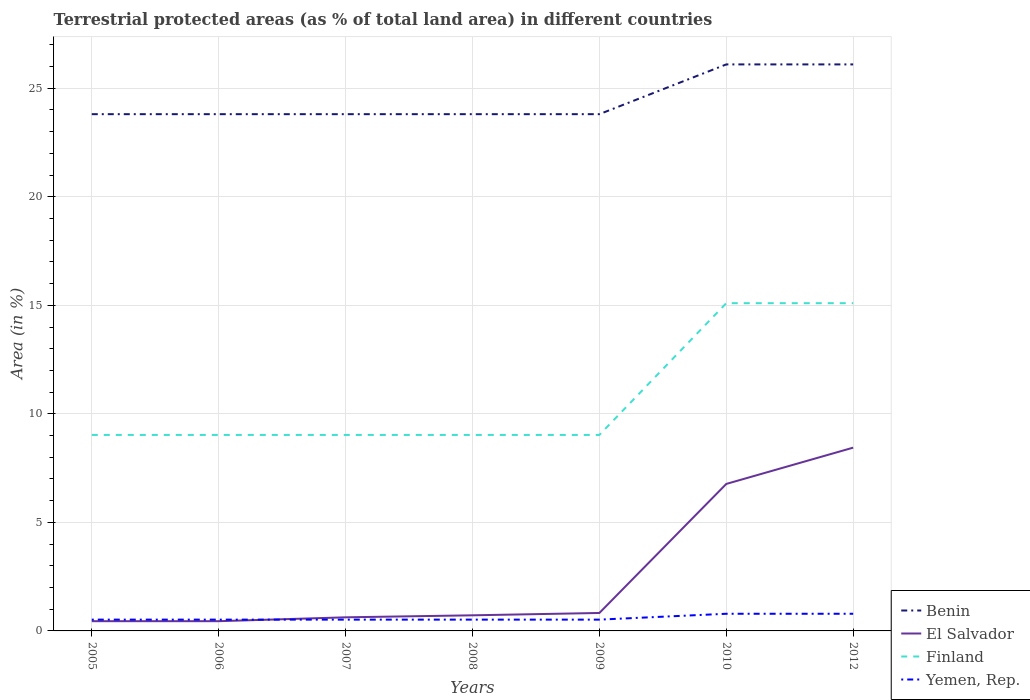How many different coloured lines are there?
Provide a short and direct response. 4. Across all years, what is the maximum percentage of terrestrial protected land in El Salvador?
Ensure brevity in your answer.  0.45. What is the total percentage of terrestrial protected land in Benin in the graph?
Keep it short and to the point. 3.0140014928292658e-9. What is the difference between the highest and the second highest percentage of terrestrial protected land in El Salvador?
Ensure brevity in your answer.  8. Is the percentage of terrestrial protected land in Benin strictly greater than the percentage of terrestrial protected land in Finland over the years?
Give a very brief answer. No. Does the graph contain any zero values?
Offer a very short reply. No. Does the graph contain grids?
Give a very brief answer. Yes. Where does the legend appear in the graph?
Give a very brief answer. Bottom right. How many legend labels are there?
Offer a very short reply. 4. How are the legend labels stacked?
Keep it short and to the point. Vertical. What is the title of the graph?
Your response must be concise. Terrestrial protected areas (as % of total land area) in different countries. What is the label or title of the Y-axis?
Your response must be concise. Area (in %). What is the Area (in %) of Benin in 2005?
Your answer should be compact. 23.81. What is the Area (in %) of El Salvador in 2005?
Offer a terse response. 0.45. What is the Area (in %) in Finland in 2005?
Your answer should be compact. 9.03. What is the Area (in %) in Yemen, Rep. in 2005?
Your answer should be compact. 0.52. What is the Area (in %) of Benin in 2006?
Your response must be concise. 23.81. What is the Area (in %) of El Salvador in 2006?
Keep it short and to the point. 0.45. What is the Area (in %) of Finland in 2006?
Offer a very short reply. 9.03. What is the Area (in %) in Yemen, Rep. in 2006?
Offer a terse response. 0.52. What is the Area (in %) in Benin in 2007?
Your answer should be very brief. 23.81. What is the Area (in %) of El Salvador in 2007?
Offer a very short reply. 0.63. What is the Area (in %) of Finland in 2007?
Give a very brief answer. 9.03. What is the Area (in %) in Yemen, Rep. in 2007?
Your answer should be very brief. 0.52. What is the Area (in %) of Benin in 2008?
Your answer should be very brief. 23.81. What is the Area (in %) of El Salvador in 2008?
Provide a short and direct response. 0.72. What is the Area (in %) of Finland in 2008?
Give a very brief answer. 9.03. What is the Area (in %) in Yemen, Rep. in 2008?
Offer a terse response. 0.52. What is the Area (in %) of Benin in 2009?
Offer a terse response. 23.81. What is the Area (in %) of El Salvador in 2009?
Your response must be concise. 0.83. What is the Area (in %) of Finland in 2009?
Provide a short and direct response. 9.03. What is the Area (in %) of Yemen, Rep. in 2009?
Offer a terse response. 0.52. What is the Area (in %) of Benin in 2010?
Offer a very short reply. 26.1. What is the Area (in %) in El Salvador in 2010?
Make the answer very short. 6.77. What is the Area (in %) in Finland in 2010?
Offer a very short reply. 15.1. What is the Area (in %) in Yemen, Rep. in 2010?
Provide a succinct answer. 0.79. What is the Area (in %) of Benin in 2012?
Your answer should be compact. 26.1. What is the Area (in %) in El Salvador in 2012?
Your response must be concise. 8.44. What is the Area (in %) in Finland in 2012?
Your answer should be compact. 15.1. What is the Area (in %) in Yemen, Rep. in 2012?
Keep it short and to the point. 0.79. Across all years, what is the maximum Area (in %) in Benin?
Provide a short and direct response. 26.1. Across all years, what is the maximum Area (in %) of El Salvador?
Keep it short and to the point. 8.44. Across all years, what is the maximum Area (in %) in Finland?
Provide a succinct answer. 15.1. Across all years, what is the maximum Area (in %) of Yemen, Rep.?
Your answer should be very brief. 0.79. Across all years, what is the minimum Area (in %) of Benin?
Provide a succinct answer. 23.81. Across all years, what is the minimum Area (in %) of El Salvador?
Offer a terse response. 0.45. Across all years, what is the minimum Area (in %) of Finland?
Provide a short and direct response. 9.03. Across all years, what is the minimum Area (in %) in Yemen, Rep.?
Your answer should be compact. 0.52. What is the total Area (in %) in Benin in the graph?
Give a very brief answer. 171.24. What is the total Area (in %) of El Salvador in the graph?
Keep it short and to the point. 18.28. What is the total Area (in %) of Finland in the graph?
Provide a succinct answer. 75.34. What is the total Area (in %) in Yemen, Rep. in the graph?
Offer a very short reply. 4.18. What is the difference between the Area (in %) of Benin in 2005 and that in 2006?
Your response must be concise. 0. What is the difference between the Area (in %) in El Salvador in 2005 and that in 2006?
Your answer should be compact. 0. What is the difference between the Area (in %) of Finland in 2005 and that in 2006?
Offer a very short reply. -0. What is the difference between the Area (in %) of Benin in 2005 and that in 2007?
Offer a terse response. 0. What is the difference between the Area (in %) of El Salvador in 2005 and that in 2007?
Ensure brevity in your answer.  -0.18. What is the difference between the Area (in %) in Finland in 2005 and that in 2007?
Provide a short and direct response. -0. What is the difference between the Area (in %) in Yemen, Rep. in 2005 and that in 2007?
Provide a short and direct response. 0. What is the difference between the Area (in %) in Benin in 2005 and that in 2008?
Your response must be concise. 0. What is the difference between the Area (in %) of El Salvador in 2005 and that in 2008?
Give a very brief answer. -0.27. What is the difference between the Area (in %) in Finland in 2005 and that in 2008?
Make the answer very short. -0. What is the difference between the Area (in %) of Benin in 2005 and that in 2009?
Provide a succinct answer. 0. What is the difference between the Area (in %) of El Salvador in 2005 and that in 2009?
Give a very brief answer. -0.38. What is the difference between the Area (in %) of Yemen, Rep. in 2005 and that in 2009?
Offer a terse response. 0. What is the difference between the Area (in %) of Benin in 2005 and that in 2010?
Offer a very short reply. -2.29. What is the difference between the Area (in %) in El Salvador in 2005 and that in 2010?
Give a very brief answer. -6.32. What is the difference between the Area (in %) of Finland in 2005 and that in 2010?
Your answer should be compact. -6.07. What is the difference between the Area (in %) in Yemen, Rep. in 2005 and that in 2010?
Keep it short and to the point. -0.27. What is the difference between the Area (in %) of Benin in 2005 and that in 2012?
Ensure brevity in your answer.  -2.29. What is the difference between the Area (in %) in El Salvador in 2005 and that in 2012?
Offer a very short reply. -8. What is the difference between the Area (in %) in Finland in 2005 and that in 2012?
Make the answer very short. -6.07. What is the difference between the Area (in %) of Yemen, Rep. in 2005 and that in 2012?
Your response must be concise. -0.27. What is the difference between the Area (in %) in El Salvador in 2006 and that in 2007?
Make the answer very short. -0.18. What is the difference between the Area (in %) in Benin in 2006 and that in 2008?
Your answer should be compact. 0. What is the difference between the Area (in %) of El Salvador in 2006 and that in 2008?
Your response must be concise. -0.27. What is the difference between the Area (in %) of Finland in 2006 and that in 2008?
Provide a succinct answer. -0. What is the difference between the Area (in %) in Benin in 2006 and that in 2009?
Give a very brief answer. 0. What is the difference between the Area (in %) in El Salvador in 2006 and that in 2009?
Your answer should be compact. -0.38. What is the difference between the Area (in %) of Yemen, Rep. in 2006 and that in 2009?
Your response must be concise. 0. What is the difference between the Area (in %) of Benin in 2006 and that in 2010?
Your answer should be very brief. -2.29. What is the difference between the Area (in %) of El Salvador in 2006 and that in 2010?
Provide a short and direct response. -6.32. What is the difference between the Area (in %) of Finland in 2006 and that in 2010?
Offer a terse response. -6.07. What is the difference between the Area (in %) of Yemen, Rep. in 2006 and that in 2010?
Offer a very short reply. -0.27. What is the difference between the Area (in %) of Benin in 2006 and that in 2012?
Offer a very short reply. -2.29. What is the difference between the Area (in %) in El Salvador in 2006 and that in 2012?
Give a very brief answer. -8. What is the difference between the Area (in %) in Finland in 2006 and that in 2012?
Offer a very short reply. -6.07. What is the difference between the Area (in %) of Yemen, Rep. in 2006 and that in 2012?
Ensure brevity in your answer.  -0.27. What is the difference between the Area (in %) in Benin in 2007 and that in 2008?
Make the answer very short. 0. What is the difference between the Area (in %) of El Salvador in 2007 and that in 2008?
Offer a very short reply. -0.09. What is the difference between the Area (in %) of Finland in 2007 and that in 2008?
Provide a short and direct response. -0. What is the difference between the Area (in %) of El Salvador in 2007 and that in 2009?
Make the answer very short. -0.2. What is the difference between the Area (in %) of Yemen, Rep. in 2007 and that in 2009?
Your response must be concise. 0. What is the difference between the Area (in %) of Benin in 2007 and that in 2010?
Provide a short and direct response. -2.29. What is the difference between the Area (in %) of El Salvador in 2007 and that in 2010?
Keep it short and to the point. -6.14. What is the difference between the Area (in %) in Finland in 2007 and that in 2010?
Give a very brief answer. -6.07. What is the difference between the Area (in %) in Yemen, Rep. in 2007 and that in 2010?
Your response must be concise. -0.27. What is the difference between the Area (in %) of Benin in 2007 and that in 2012?
Keep it short and to the point. -2.29. What is the difference between the Area (in %) in El Salvador in 2007 and that in 2012?
Ensure brevity in your answer.  -7.82. What is the difference between the Area (in %) of Finland in 2007 and that in 2012?
Provide a short and direct response. -6.07. What is the difference between the Area (in %) of Yemen, Rep. in 2007 and that in 2012?
Your response must be concise. -0.27. What is the difference between the Area (in %) in Benin in 2008 and that in 2009?
Offer a very short reply. 0. What is the difference between the Area (in %) in El Salvador in 2008 and that in 2009?
Provide a short and direct response. -0.11. What is the difference between the Area (in %) in Finland in 2008 and that in 2009?
Your answer should be very brief. -0. What is the difference between the Area (in %) of Benin in 2008 and that in 2010?
Provide a succinct answer. -2.29. What is the difference between the Area (in %) of El Salvador in 2008 and that in 2010?
Your answer should be very brief. -6.05. What is the difference between the Area (in %) of Finland in 2008 and that in 2010?
Give a very brief answer. -6.07. What is the difference between the Area (in %) in Yemen, Rep. in 2008 and that in 2010?
Offer a terse response. -0.27. What is the difference between the Area (in %) in Benin in 2008 and that in 2012?
Make the answer very short. -2.29. What is the difference between the Area (in %) in El Salvador in 2008 and that in 2012?
Your answer should be compact. -7.72. What is the difference between the Area (in %) in Finland in 2008 and that in 2012?
Offer a very short reply. -6.07. What is the difference between the Area (in %) of Yemen, Rep. in 2008 and that in 2012?
Your answer should be very brief. -0.27. What is the difference between the Area (in %) in Benin in 2009 and that in 2010?
Keep it short and to the point. -2.29. What is the difference between the Area (in %) of El Salvador in 2009 and that in 2010?
Offer a very short reply. -5.95. What is the difference between the Area (in %) in Finland in 2009 and that in 2010?
Make the answer very short. -6.07. What is the difference between the Area (in %) of Yemen, Rep. in 2009 and that in 2010?
Provide a succinct answer. -0.27. What is the difference between the Area (in %) of Benin in 2009 and that in 2012?
Ensure brevity in your answer.  -2.29. What is the difference between the Area (in %) in El Salvador in 2009 and that in 2012?
Your answer should be compact. -7.62. What is the difference between the Area (in %) of Finland in 2009 and that in 2012?
Offer a very short reply. -6.07. What is the difference between the Area (in %) of Yemen, Rep. in 2009 and that in 2012?
Your answer should be very brief. -0.27. What is the difference between the Area (in %) of Benin in 2010 and that in 2012?
Give a very brief answer. 0. What is the difference between the Area (in %) of El Salvador in 2010 and that in 2012?
Offer a terse response. -1.67. What is the difference between the Area (in %) in Finland in 2010 and that in 2012?
Your answer should be very brief. 0. What is the difference between the Area (in %) in Yemen, Rep. in 2010 and that in 2012?
Provide a succinct answer. 0. What is the difference between the Area (in %) of Benin in 2005 and the Area (in %) of El Salvador in 2006?
Your response must be concise. 23.36. What is the difference between the Area (in %) of Benin in 2005 and the Area (in %) of Finland in 2006?
Make the answer very short. 14.78. What is the difference between the Area (in %) in Benin in 2005 and the Area (in %) in Yemen, Rep. in 2006?
Ensure brevity in your answer.  23.29. What is the difference between the Area (in %) of El Salvador in 2005 and the Area (in %) of Finland in 2006?
Make the answer very short. -8.58. What is the difference between the Area (in %) in El Salvador in 2005 and the Area (in %) in Yemen, Rep. in 2006?
Your answer should be compact. -0.07. What is the difference between the Area (in %) of Finland in 2005 and the Area (in %) of Yemen, Rep. in 2006?
Your response must be concise. 8.51. What is the difference between the Area (in %) of Benin in 2005 and the Area (in %) of El Salvador in 2007?
Keep it short and to the point. 23.18. What is the difference between the Area (in %) in Benin in 2005 and the Area (in %) in Finland in 2007?
Keep it short and to the point. 14.78. What is the difference between the Area (in %) in Benin in 2005 and the Area (in %) in Yemen, Rep. in 2007?
Provide a succinct answer. 23.29. What is the difference between the Area (in %) of El Salvador in 2005 and the Area (in %) of Finland in 2007?
Your answer should be compact. -8.58. What is the difference between the Area (in %) of El Salvador in 2005 and the Area (in %) of Yemen, Rep. in 2007?
Offer a very short reply. -0.07. What is the difference between the Area (in %) in Finland in 2005 and the Area (in %) in Yemen, Rep. in 2007?
Provide a short and direct response. 8.51. What is the difference between the Area (in %) in Benin in 2005 and the Area (in %) in El Salvador in 2008?
Give a very brief answer. 23.09. What is the difference between the Area (in %) in Benin in 2005 and the Area (in %) in Finland in 2008?
Your answer should be compact. 14.78. What is the difference between the Area (in %) of Benin in 2005 and the Area (in %) of Yemen, Rep. in 2008?
Offer a very short reply. 23.29. What is the difference between the Area (in %) in El Salvador in 2005 and the Area (in %) in Finland in 2008?
Your response must be concise. -8.58. What is the difference between the Area (in %) in El Salvador in 2005 and the Area (in %) in Yemen, Rep. in 2008?
Your answer should be very brief. -0.07. What is the difference between the Area (in %) in Finland in 2005 and the Area (in %) in Yemen, Rep. in 2008?
Ensure brevity in your answer.  8.51. What is the difference between the Area (in %) of Benin in 2005 and the Area (in %) of El Salvador in 2009?
Offer a terse response. 22.98. What is the difference between the Area (in %) in Benin in 2005 and the Area (in %) in Finland in 2009?
Your response must be concise. 14.78. What is the difference between the Area (in %) in Benin in 2005 and the Area (in %) in Yemen, Rep. in 2009?
Your response must be concise. 23.29. What is the difference between the Area (in %) in El Salvador in 2005 and the Area (in %) in Finland in 2009?
Keep it short and to the point. -8.58. What is the difference between the Area (in %) of El Salvador in 2005 and the Area (in %) of Yemen, Rep. in 2009?
Keep it short and to the point. -0.07. What is the difference between the Area (in %) in Finland in 2005 and the Area (in %) in Yemen, Rep. in 2009?
Provide a short and direct response. 8.51. What is the difference between the Area (in %) in Benin in 2005 and the Area (in %) in El Salvador in 2010?
Your response must be concise. 17.04. What is the difference between the Area (in %) of Benin in 2005 and the Area (in %) of Finland in 2010?
Your answer should be very brief. 8.71. What is the difference between the Area (in %) in Benin in 2005 and the Area (in %) in Yemen, Rep. in 2010?
Offer a very short reply. 23.02. What is the difference between the Area (in %) in El Salvador in 2005 and the Area (in %) in Finland in 2010?
Ensure brevity in your answer.  -14.65. What is the difference between the Area (in %) in El Salvador in 2005 and the Area (in %) in Yemen, Rep. in 2010?
Make the answer very short. -0.34. What is the difference between the Area (in %) of Finland in 2005 and the Area (in %) of Yemen, Rep. in 2010?
Your answer should be very brief. 8.24. What is the difference between the Area (in %) of Benin in 2005 and the Area (in %) of El Salvador in 2012?
Your answer should be compact. 15.36. What is the difference between the Area (in %) in Benin in 2005 and the Area (in %) in Finland in 2012?
Ensure brevity in your answer.  8.71. What is the difference between the Area (in %) of Benin in 2005 and the Area (in %) of Yemen, Rep. in 2012?
Your response must be concise. 23.02. What is the difference between the Area (in %) in El Salvador in 2005 and the Area (in %) in Finland in 2012?
Provide a short and direct response. -14.65. What is the difference between the Area (in %) in El Salvador in 2005 and the Area (in %) in Yemen, Rep. in 2012?
Your answer should be very brief. -0.34. What is the difference between the Area (in %) of Finland in 2005 and the Area (in %) of Yemen, Rep. in 2012?
Provide a succinct answer. 8.24. What is the difference between the Area (in %) in Benin in 2006 and the Area (in %) in El Salvador in 2007?
Ensure brevity in your answer.  23.18. What is the difference between the Area (in %) in Benin in 2006 and the Area (in %) in Finland in 2007?
Provide a succinct answer. 14.78. What is the difference between the Area (in %) of Benin in 2006 and the Area (in %) of Yemen, Rep. in 2007?
Give a very brief answer. 23.29. What is the difference between the Area (in %) of El Salvador in 2006 and the Area (in %) of Finland in 2007?
Provide a short and direct response. -8.58. What is the difference between the Area (in %) in El Salvador in 2006 and the Area (in %) in Yemen, Rep. in 2007?
Your answer should be very brief. -0.07. What is the difference between the Area (in %) of Finland in 2006 and the Area (in %) of Yemen, Rep. in 2007?
Provide a short and direct response. 8.51. What is the difference between the Area (in %) of Benin in 2006 and the Area (in %) of El Salvador in 2008?
Keep it short and to the point. 23.09. What is the difference between the Area (in %) of Benin in 2006 and the Area (in %) of Finland in 2008?
Your response must be concise. 14.78. What is the difference between the Area (in %) of Benin in 2006 and the Area (in %) of Yemen, Rep. in 2008?
Provide a short and direct response. 23.29. What is the difference between the Area (in %) of El Salvador in 2006 and the Area (in %) of Finland in 2008?
Make the answer very short. -8.58. What is the difference between the Area (in %) of El Salvador in 2006 and the Area (in %) of Yemen, Rep. in 2008?
Provide a succinct answer. -0.07. What is the difference between the Area (in %) of Finland in 2006 and the Area (in %) of Yemen, Rep. in 2008?
Your answer should be very brief. 8.51. What is the difference between the Area (in %) of Benin in 2006 and the Area (in %) of El Salvador in 2009?
Offer a very short reply. 22.98. What is the difference between the Area (in %) in Benin in 2006 and the Area (in %) in Finland in 2009?
Your answer should be very brief. 14.78. What is the difference between the Area (in %) of Benin in 2006 and the Area (in %) of Yemen, Rep. in 2009?
Ensure brevity in your answer.  23.29. What is the difference between the Area (in %) of El Salvador in 2006 and the Area (in %) of Finland in 2009?
Keep it short and to the point. -8.58. What is the difference between the Area (in %) in El Salvador in 2006 and the Area (in %) in Yemen, Rep. in 2009?
Offer a terse response. -0.07. What is the difference between the Area (in %) of Finland in 2006 and the Area (in %) of Yemen, Rep. in 2009?
Offer a terse response. 8.51. What is the difference between the Area (in %) of Benin in 2006 and the Area (in %) of El Salvador in 2010?
Your response must be concise. 17.04. What is the difference between the Area (in %) in Benin in 2006 and the Area (in %) in Finland in 2010?
Provide a succinct answer. 8.71. What is the difference between the Area (in %) in Benin in 2006 and the Area (in %) in Yemen, Rep. in 2010?
Offer a very short reply. 23.02. What is the difference between the Area (in %) of El Salvador in 2006 and the Area (in %) of Finland in 2010?
Keep it short and to the point. -14.65. What is the difference between the Area (in %) in El Salvador in 2006 and the Area (in %) in Yemen, Rep. in 2010?
Provide a short and direct response. -0.34. What is the difference between the Area (in %) in Finland in 2006 and the Area (in %) in Yemen, Rep. in 2010?
Offer a very short reply. 8.24. What is the difference between the Area (in %) in Benin in 2006 and the Area (in %) in El Salvador in 2012?
Your answer should be very brief. 15.36. What is the difference between the Area (in %) of Benin in 2006 and the Area (in %) of Finland in 2012?
Ensure brevity in your answer.  8.71. What is the difference between the Area (in %) in Benin in 2006 and the Area (in %) in Yemen, Rep. in 2012?
Your answer should be very brief. 23.02. What is the difference between the Area (in %) of El Salvador in 2006 and the Area (in %) of Finland in 2012?
Ensure brevity in your answer.  -14.65. What is the difference between the Area (in %) of El Salvador in 2006 and the Area (in %) of Yemen, Rep. in 2012?
Your answer should be compact. -0.34. What is the difference between the Area (in %) of Finland in 2006 and the Area (in %) of Yemen, Rep. in 2012?
Your answer should be compact. 8.24. What is the difference between the Area (in %) in Benin in 2007 and the Area (in %) in El Salvador in 2008?
Offer a terse response. 23.09. What is the difference between the Area (in %) of Benin in 2007 and the Area (in %) of Finland in 2008?
Your response must be concise. 14.78. What is the difference between the Area (in %) in Benin in 2007 and the Area (in %) in Yemen, Rep. in 2008?
Your response must be concise. 23.29. What is the difference between the Area (in %) in El Salvador in 2007 and the Area (in %) in Finland in 2008?
Keep it short and to the point. -8.4. What is the difference between the Area (in %) in El Salvador in 2007 and the Area (in %) in Yemen, Rep. in 2008?
Provide a succinct answer. 0.11. What is the difference between the Area (in %) in Finland in 2007 and the Area (in %) in Yemen, Rep. in 2008?
Your response must be concise. 8.51. What is the difference between the Area (in %) in Benin in 2007 and the Area (in %) in El Salvador in 2009?
Keep it short and to the point. 22.98. What is the difference between the Area (in %) of Benin in 2007 and the Area (in %) of Finland in 2009?
Provide a short and direct response. 14.78. What is the difference between the Area (in %) of Benin in 2007 and the Area (in %) of Yemen, Rep. in 2009?
Keep it short and to the point. 23.29. What is the difference between the Area (in %) of El Salvador in 2007 and the Area (in %) of Finland in 2009?
Your answer should be compact. -8.4. What is the difference between the Area (in %) of El Salvador in 2007 and the Area (in %) of Yemen, Rep. in 2009?
Provide a short and direct response. 0.11. What is the difference between the Area (in %) of Finland in 2007 and the Area (in %) of Yemen, Rep. in 2009?
Provide a short and direct response. 8.51. What is the difference between the Area (in %) of Benin in 2007 and the Area (in %) of El Salvador in 2010?
Your answer should be compact. 17.04. What is the difference between the Area (in %) of Benin in 2007 and the Area (in %) of Finland in 2010?
Keep it short and to the point. 8.71. What is the difference between the Area (in %) in Benin in 2007 and the Area (in %) in Yemen, Rep. in 2010?
Your response must be concise. 23.02. What is the difference between the Area (in %) in El Salvador in 2007 and the Area (in %) in Finland in 2010?
Make the answer very short. -14.47. What is the difference between the Area (in %) in El Salvador in 2007 and the Area (in %) in Yemen, Rep. in 2010?
Offer a terse response. -0.16. What is the difference between the Area (in %) in Finland in 2007 and the Area (in %) in Yemen, Rep. in 2010?
Make the answer very short. 8.24. What is the difference between the Area (in %) of Benin in 2007 and the Area (in %) of El Salvador in 2012?
Your answer should be very brief. 15.36. What is the difference between the Area (in %) of Benin in 2007 and the Area (in %) of Finland in 2012?
Provide a short and direct response. 8.71. What is the difference between the Area (in %) of Benin in 2007 and the Area (in %) of Yemen, Rep. in 2012?
Give a very brief answer. 23.02. What is the difference between the Area (in %) of El Salvador in 2007 and the Area (in %) of Finland in 2012?
Your response must be concise. -14.47. What is the difference between the Area (in %) in El Salvador in 2007 and the Area (in %) in Yemen, Rep. in 2012?
Ensure brevity in your answer.  -0.16. What is the difference between the Area (in %) in Finland in 2007 and the Area (in %) in Yemen, Rep. in 2012?
Offer a very short reply. 8.24. What is the difference between the Area (in %) of Benin in 2008 and the Area (in %) of El Salvador in 2009?
Your response must be concise. 22.98. What is the difference between the Area (in %) in Benin in 2008 and the Area (in %) in Finland in 2009?
Make the answer very short. 14.78. What is the difference between the Area (in %) in Benin in 2008 and the Area (in %) in Yemen, Rep. in 2009?
Your answer should be compact. 23.29. What is the difference between the Area (in %) of El Salvador in 2008 and the Area (in %) of Finland in 2009?
Provide a succinct answer. -8.31. What is the difference between the Area (in %) of El Salvador in 2008 and the Area (in %) of Yemen, Rep. in 2009?
Keep it short and to the point. 0.2. What is the difference between the Area (in %) in Finland in 2008 and the Area (in %) in Yemen, Rep. in 2009?
Offer a terse response. 8.51. What is the difference between the Area (in %) of Benin in 2008 and the Area (in %) of El Salvador in 2010?
Your response must be concise. 17.04. What is the difference between the Area (in %) of Benin in 2008 and the Area (in %) of Finland in 2010?
Ensure brevity in your answer.  8.71. What is the difference between the Area (in %) in Benin in 2008 and the Area (in %) in Yemen, Rep. in 2010?
Ensure brevity in your answer.  23.02. What is the difference between the Area (in %) of El Salvador in 2008 and the Area (in %) of Finland in 2010?
Provide a short and direct response. -14.38. What is the difference between the Area (in %) of El Salvador in 2008 and the Area (in %) of Yemen, Rep. in 2010?
Make the answer very short. -0.07. What is the difference between the Area (in %) of Finland in 2008 and the Area (in %) of Yemen, Rep. in 2010?
Your response must be concise. 8.24. What is the difference between the Area (in %) of Benin in 2008 and the Area (in %) of El Salvador in 2012?
Your answer should be very brief. 15.36. What is the difference between the Area (in %) in Benin in 2008 and the Area (in %) in Finland in 2012?
Your answer should be very brief. 8.71. What is the difference between the Area (in %) of Benin in 2008 and the Area (in %) of Yemen, Rep. in 2012?
Your answer should be compact. 23.02. What is the difference between the Area (in %) of El Salvador in 2008 and the Area (in %) of Finland in 2012?
Offer a very short reply. -14.38. What is the difference between the Area (in %) in El Salvador in 2008 and the Area (in %) in Yemen, Rep. in 2012?
Offer a terse response. -0.07. What is the difference between the Area (in %) in Finland in 2008 and the Area (in %) in Yemen, Rep. in 2012?
Your answer should be very brief. 8.24. What is the difference between the Area (in %) of Benin in 2009 and the Area (in %) of El Salvador in 2010?
Keep it short and to the point. 17.04. What is the difference between the Area (in %) of Benin in 2009 and the Area (in %) of Finland in 2010?
Provide a succinct answer. 8.71. What is the difference between the Area (in %) of Benin in 2009 and the Area (in %) of Yemen, Rep. in 2010?
Keep it short and to the point. 23.02. What is the difference between the Area (in %) in El Salvador in 2009 and the Area (in %) in Finland in 2010?
Your answer should be compact. -14.27. What is the difference between the Area (in %) of El Salvador in 2009 and the Area (in %) of Yemen, Rep. in 2010?
Keep it short and to the point. 0.04. What is the difference between the Area (in %) in Finland in 2009 and the Area (in %) in Yemen, Rep. in 2010?
Make the answer very short. 8.24. What is the difference between the Area (in %) in Benin in 2009 and the Area (in %) in El Salvador in 2012?
Ensure brevity in your answer.  15.36. What is the difference between the Area (in %) of Benin in 2009 and the Area (in %) of Finland in 2012?
Give a very brief answer. 8.71. What is the difference between the Area (in %) in Benin in 2009 and the Area (in %) in Yemen, Rep. in 2012?
Make the answer very short. 23.02. What is the difference between the Area (in %) in El Salvador in 2009 and the Area (in %) in Finland in 2012?
Keep it short and to the point. -14.27. What is the difference between the Area (in %) of El Salvador in 2009 and the Area (in %) of Yemen, Rep. in 2012?
Make the answer very short. 0.04. What is the difference between the Area (in %) of Finland in 2009 and the Area (in %) of Yemen, Rep. in 2012?
Provide a short and direct response. 8.24. What is the difference between the Area (in %) in Benin in 2010 and the Area (in %) in El Salvador in 2012?
Your response must be concise. 17.66. What is the difference between the Area (in %) in Benin in 2010 and the Area (in %) in Finland in 2012?
Provide a succinct answer. 11. What is the difference between the Area (in %) in Benin in 2010 and the Area (in %) in Yemen, Rep. in 2012?
Provide a short and direct response. 25.31. What is the difference between the Area (in %) of El Salvador in 2010 and the Area (in %) of Finland in 2012?
Your response must be concise. -8.33. What is the difference between the Area (in %) in El Salvador in 2010 and the Area (in %) in Yemen, Rep. in 2012?
Your answer should be very brief. 5.98. What is the difference between the Area (in %) of Finland in 2010 and the Area (in %) of Yemen, Rep. in 2012?
Provide a succinct answer. 14.31. What is the average Area (in %) of Benin per year?
Provide a short and direct response. 24.46. What is the average Area (in %) in El Salvador per year?
Your answer should be very brief. 2.61. What is the average Area (in %) of Finland per year?
Keep it short and to the point. 10.76. What is the average Area (in %) of Yemen, Rep. per year?
Your answer should be very brief. 0.6. In the year 2005, what is the difference between the Area (in %) of Benin and Area (in %) of El Salvador?
Keep it short and to the point. 23.36. In the year 2005, what is the difference between the Area (in %) in Benin and Area (in %) in Finland?
Give a very brief answer. 14.78. In the year 2005, what is the difference between the Area (in %) in Benin and Area (in %) in Yemen, Rep.?
Offer a terse response. 23.29. In the year 2005, what is the difference between the Area (in %) of El Salvador and Area (in %) of Finland?
Your answer should be compact. -8.58. In the year 2005, what is the difference between the Area (in %) of El Salvador and Area (in %) of Yemen, Rep.?
Give a very brief answer. -0.07. In the year 2005, what is the difference between the Area (in %) in Finland and Area (in %) in Yemen, Rep.?
Your answer should be compact. 8.51. In the year 2006, what is the difference between the Area (in %) of Benin and Area (in %) of El Salvador?
Your answer should be very brief. 23.36. In the year 2006, what is the difference between the Area (in %) of Benin and Area (in %) of Finland?
Provide a succinct answer. 14.78. In the year 2006, what is the difference between the Area (in %) in Benin and Area (in %) in Yemen, Rep.?
Your response must be concise. 23.29. In the year 2006, what is the difference between the Area (in %) in El Salvador and Area (in %) in Finland?
Your response must be concise. -8.58. In the year 2006, what is the difference between the Area (in %) of El Salvador and Area (in %) of Yemen, Rep.?
Provide a short and direct response. -0.07. In the year 2006, what is the difference between the Area (in %) in Finland and Area (in %) in Yemen, Rep.?
Your response must be concise. 8.51. In the year 2007, what is the difference between the Area (in %) of Benin and Area (in %) of El Salvador?
Give a very brief answer. 23.18. In the year 2007, what is the difference between the Area (in %) in Benin and Area (in %) in Finland?
Provide a succinct answer. 14.78. In the year 2007, what is the difference between the Area (in %) of Benin and Area (in %) of Yemen, Rep.?
Your answer should be compact. 23.29. In the year 2007, what is the difference between the Area (in %) of El Salvador and Area (in %) of Finland?
Keep it short and to the point. -8.4. In the year 2007, what is the difference between the Area (in %) in El Salvador and Area (in %) in Yemen, Rep.?
Your answer should be very brief. 0.11. In the year 2007, what is the difference between the Area (in %) of Finland and Area (in %) of Yemen, Rep.?
Your answer should be compact. 8.51. In the year 2008, what is the difference between the Area (in %) of Benin and Area (in %) of El Salvador?
Ensure brevity in your answer.  23.09. In the year 2008, what is the difference between the Area (in %) of Benin and Area (in %) of Finland?
Provide a succinct answer. 14.78. In the year 2008, what is the difference between the Area (in %) in Benin and Area (in %) in Yemen, Rep.?
Ensure brevity in your answer.  23.29. In the year 2008, what is the difference between the Area (in %) in El Salvador and Area (in %) in Finland?
Your response must be concise. -8.31. In the year 2008, what is the difference between the Area (in %) of El Salvador and Area (in %) of Yemen, Rep.?
Keep it short and to the point. 0.2. In the year 2008, what is the difference between the Area (in %) of Finland and Area (in %) of Yemen, Rep.?
Make the answer very short. 8.51. In the year 2009, what is the difference between the Area (in %) in Benin and Area (in %) in El Salvador?
Provide a succinct answer. 22.98. In the year 2009, what is the difference between the Area (in %) in Benin and Area (in %) in Finland?
Ensure brevity in your answer.  14.78. In the year 2009, what is the difference between the Area (in %) in Benin and Area (in %) in Yemen, Rep.?
Offer a very short reply. 23.29. In the year 2009, what is the difference between the Area (in %) in El Salvador and Area (in %) in Finland?
Keep it short and to the point. -8.2. In the year 2009, what is the difference between the Area (in %) of El Salvador and Area (in %) of Yemen, Rep.?
Ensure brevity in your answer.  0.31. In the year 2009, what is the difference between the Area (in %) in Finland and Area (in %) in Yemen, Rep.?
Your answer should be compact. 8.51. In the year 2010, what is the difference between the Area (in %) of Benin and Area (in %) of El Salvador?
Ensure brevity in your answer.  19.33. In the year 2010, what is the difference between the Area (in %) of Benin and Area (in %) of Finland?
Your response must be concise. 11. In the year 2010, what is the difference between the Area (in %) in Benin and Area (in %) in Yemen, Rep.?
Make the answer very short. 25.31. In the year 2010, what is the difference between the Area (in %) of El Salvador and Area (in %) of Finland?
Your answer should be very brief. -8.33. In the year 2010, what is the difference between the Area (in %) of El Salvador and Area (in %) of Yemen, Rep.?
Ensure brevity in your answer.  5.98. In the year 2010, what is the difference between the Area (in %) of Finland and Area (in %) of Yemen, Rep.?
Make the answer very short. 14.31. In the year 2012, what is the difference between the Area (in %) of Benin and Area (in %) of El Salvador?
Offer a very short reply. 17.66. In the year 2012, what is the difference between the Area (in %) in Benin and Area (in %) in Finland?
Your answer should be compact. 11. In the year 2012, what is the difference between the Area (in %) of Benin and Area (in %) of Yemen, Rep.?
Offer a very short reply. 25.31. In the year 2012, what is the difference between the Area (in %) in El Salvador and Area (in %) in Finland?
Offer a terse response. -6.66. In the year 2012, what is the difference between the Area (in %) in El Salvador and Area (in %) in Yemen, Rep.?
Make the answer very short. 7.65. In the year 2012, what is the difference between the Area (in %) in Finland and Area (in %) in Yemen, Rep.?
Offer a very short reply. 14.31. What is the ratio of the Area (in %) in Benin in 2005 to that in 2006?
Keep it short and to the point. 1. What is the ratio of the Area (in %) in Finland in 2005 to that in 2006?
Offer a very short reply. 1. What is the ratio of the Area (in %) in Benin in 2005 to that in 2007?
Keep it short and to the point. 1. What is the ratio of the Area (in %) in El Salvador in 2005 to that in 2007?
Your answer should be very brief. 0.71. What is the ratio of the Area (in %) of Finland in 2005 to that in 2007?
Keep it short and to the point. 1. What is the ratio of the Area (in %) in Yemen, Rep. in 2005 to that in 2007?
Offer a very short reply. 1. What is the ratio of the Area (in %) in El Salvador in 2005 to that in 2008?
Give a very brief answer. 0.62. What is the ratio of the Area (in %) of Yemen, Rep. in 2005 to that in 2008?
Make the answer very short. 1. What is the ratio of the Area (in %) of Benin in 2005 to that in 2009?
Your answer should be very brief. 1. What is the ratio of the Area (in %) of El Salvador in 2005 to that in 2009?
Offer a terse response. 0.54. What is the ratio of the Area (in %) of Benin in 2005 to that in 2010?
Offer a very short reply. 0.91. What is the ratio of the Area (in %) in El Salvador in 2005 to that in 2010?
Make the answer very short. 0.07. What is the ratio of the Area (in %) in Finland in 2005 to that in 2010?
Give a very brief answer. 0.6. What is the ratio of the Area (in %) of Yemen, Rep. in 2005 to that in 2010?
Provide a short and direct response. 0.66. What is the ratio of the Area (in %) of Benin in 2005 to that in 2012?
Your response must be concise. 0.91. What is the ratio of the Area (in %) of El Salvador in 2005 to that in 2012?
Offer a very short reply. 0.05. What is the ratio of the Area (in %) of Finland in 2005 to that in 2012?
Ensure brevity in your answer.  0.6. What is the ratio of the Area (in %) of Yemen, Rep. in 2005 to that in 2012?
Your answer should be compact. 0.66. What is the ratio of the Area (in %) of El Salvador in 2006 to that in 2007?
Keep it short and to the point. 0.71. What is the ratio of the Area (in %) in Finland in 2006 to that in 2007?
Keep it short and to the point. 1. What is the ratio of the Area (in %) in Yemen, Rep. in 2006 to that in 2007?
Make the answer very short. 1. What is the ratio of the Area (in %) in El Salvador in 2006 to that in 2008?
Provide a succinct answer. 0.62. What is the ratio of the Area (in %) in Finland in 2006 to that in 2008?
Your response must be concise. 1. What is the ratio of the Area (in %) in Benin in 2006 to that in 2009?
Your answer should be very brief. 1. What is the ratio of the Area (in %) of El Salvador in 2006 to that in 2009?
Your answer should be very brief. 0.54. What is the ratio of the Area (in %) in Yemen, Rep. in 2006 to that in 2009?
Provide a succinct answer. 1. What is the ratio of the Area (in %) of Benin in 2006 to that in 2010?
Keep it short and to the point. 0.91. What is the ratio of the Area (in %) of El Salvador in 2006 to that in 2010?
Your answer should be very brief. 0.07. What is the ratio of the Area (in %) in Finland in 2006 to that in 2010?
Offer a terse response. 0.6. What is the ratio of the Area (in %) in Yemen, Rep. in 2006 to that in 2010?
Ensure brevity in your answer.  0.66. What is the ratio of the Area (in %) in Benin in 2006 to that in 2012?
Make the answer very short. 0.91. What is the ratio of the Area (in %) of El Salvador in 2006 to that in 2012?
Your answer should be very brief. 0.05. What is the ratio of the Area (in %) in Finland in 2006 to that in 2012?
Your answer should be compact. 0.6. What is the ratio of the Area (in %) of Yemen, Rep. in 2006 to that in 2012?
Make the answer very short. 0.66. What is the ratio of the Area (in %) in El Salvador in 2007 to that in 2008?
Make the answer very short. 0.87. What is the ratio of the Area (in %) in Finland in 2007 to that in 2008?
Offer a very short reply. 1. What is the ratio of the Area (in %) of Yemen, Rep. in 2007 to that in 2008?
Ensure brevity in your answer.  1. What is the ratio of the Area (in %) in Benin in 2007 to that in 2009?
Give a very brief answer. 1. What is the ratio of the Area (in %) in El Salvador in 2007 to that in 2009?
Your answer should be compact. 0.76. What is the ratio of the Area (in %) of Benin in 2007 to that in 2010?
Make the answer very short. 0.91. What is the ratio of the Area (in %) of El Salvador in 2007 to that in 2010?
Offer a very short reply. 0.09. What is the ratio of the Area (in %) in Finland in 2007 to that in 2010?
Offer a very short reply. 0.6. What is the ratio of the Area (in %) in Yemen, Rep. in 2007 to that in 2010?
Keep it short and to the point. 0.66. What is the ratio of the Area (in %) in Benin in 2007 to that in 2012?
Offer a terse response. 0.91. What is the ratio of the Area (in %) of El Salvador in 2007 to that in 2012?
Ensure brevity in your answer.  0.07. What is the ratio of the Area (in %) of Finland in 2007 to that in 2012?
Your answer should be very brief. 0.6. What is the ratio of the Area (in %) in Yemen, Rep. in 2007 to that in 2012?
Make the answer very short. 0.66. What is the ratio of the Area (in %) in Benin in 2008 to that in 2009?
Your response must be concise. 1. What is the ratio of the Area (in %) in El Salvador in 2008 to that in 2009?
Give a very brief answer. 0.87. What is the ratio of the Area (in %) of Finland in 2008 to that in 2009?
Your answer should be very brief. 1. What is the ratio of the Area (in %) in Yemen, Rep. in 2008 to that in 2009?
Provide a short and direct response. 1. What is the ratio of the Area (in %) in Benin in 2008 to that in 2010?
Your answer should be very brief. 0.91. What is the ratio of the Area (in %) in El Salvador in 2008 to that in 2010?
Your answer should be very brief. 0.11. What is the ratio of the Area (in %) in Finland in 2008 to that in 2010?
Your response must be concise. 0.6. What is the ratio of the Area (in %) in Yemen, Rep. in 2008 to that in 2010?
Your answer should be very brief. 0.66. What is the ratio of the Area (in %) of Benin in 2008 to that in 2012?
Offer a terse response. 0.91. What is the ratio of the Area (in %) in El Salvador in 2008 to that in 2012?
Give a very brief answer. 0.09. What is the ratio of the Area (in %) in Finland in 2008 to that in 2012?
Your answer should be compact. 0.6. What is the ratio of the Area (in %) of Yemen, Rep. in 2008 to that in 2012?
Make the answer very short. 0.66. What is the ratio of the Area (in %) in Benin in 2009 to that in 2010?
Provide a short and direct response. 0.91. What is the ratio of the Area (in %) of El Salvador in 2009 to that in 2010?
Your response must be concise. 0.12. What is the ratio of the Area (in %) in Finland in 2009 to that in 2010?
Your response must be concise. 0.6. What is the ratio of the Area (in %) in Yemen, Rep. in 2009 to that in 2010?
Offer a very short reply. 0.66. What is the ratio of the Area (in %) of Benin in 2009 to that in 2012?
Your answer should be compact. 0.91. What is the ratio of the Area (in %) of El Salvador in 2009 to that in 2012?
Offer a very short reply. 0.1. What is the ratio of the Area (in %) of Finland in 2009 to that in 2012?
Your response must be concise. 0.6. What is the ratio of the Area (in %) of Yemen, Rep. in 2009 to that in 2012?
Your answer should be very brief. 0.66. What is the ratio of the Area (in %) in El Salvador in 2010 to that in 2012?
Ensure brevity in your answer.  0.8. What is the ratio of the Area (in %) in Finland in 2010 to that in 2012?
Your answer should be compact. 1. What is the difference between the highest and the second highest Area (in %) of El Salvador?
Your answer should be compact. 1.67. What is the difference between the highest and the second highest Area (in %) of Finland?
Provide a succinct answer. 0. What is the difference between the highest and the lowest Area (in %) of Benin?
Your response must be concise. 2.29. What is the difference between the highest and the lowest Area (in %) in El Salvador?
Ensure brevity in your answer.  8. What is the difference between the highest and the lowest Area (in %) in Finland?
Your answer should be very brief. 6.07. What is the difference between the highest and the lowest Area (in %) of Yemen, Rep.?
Provide a short and direct response. 0.27. 